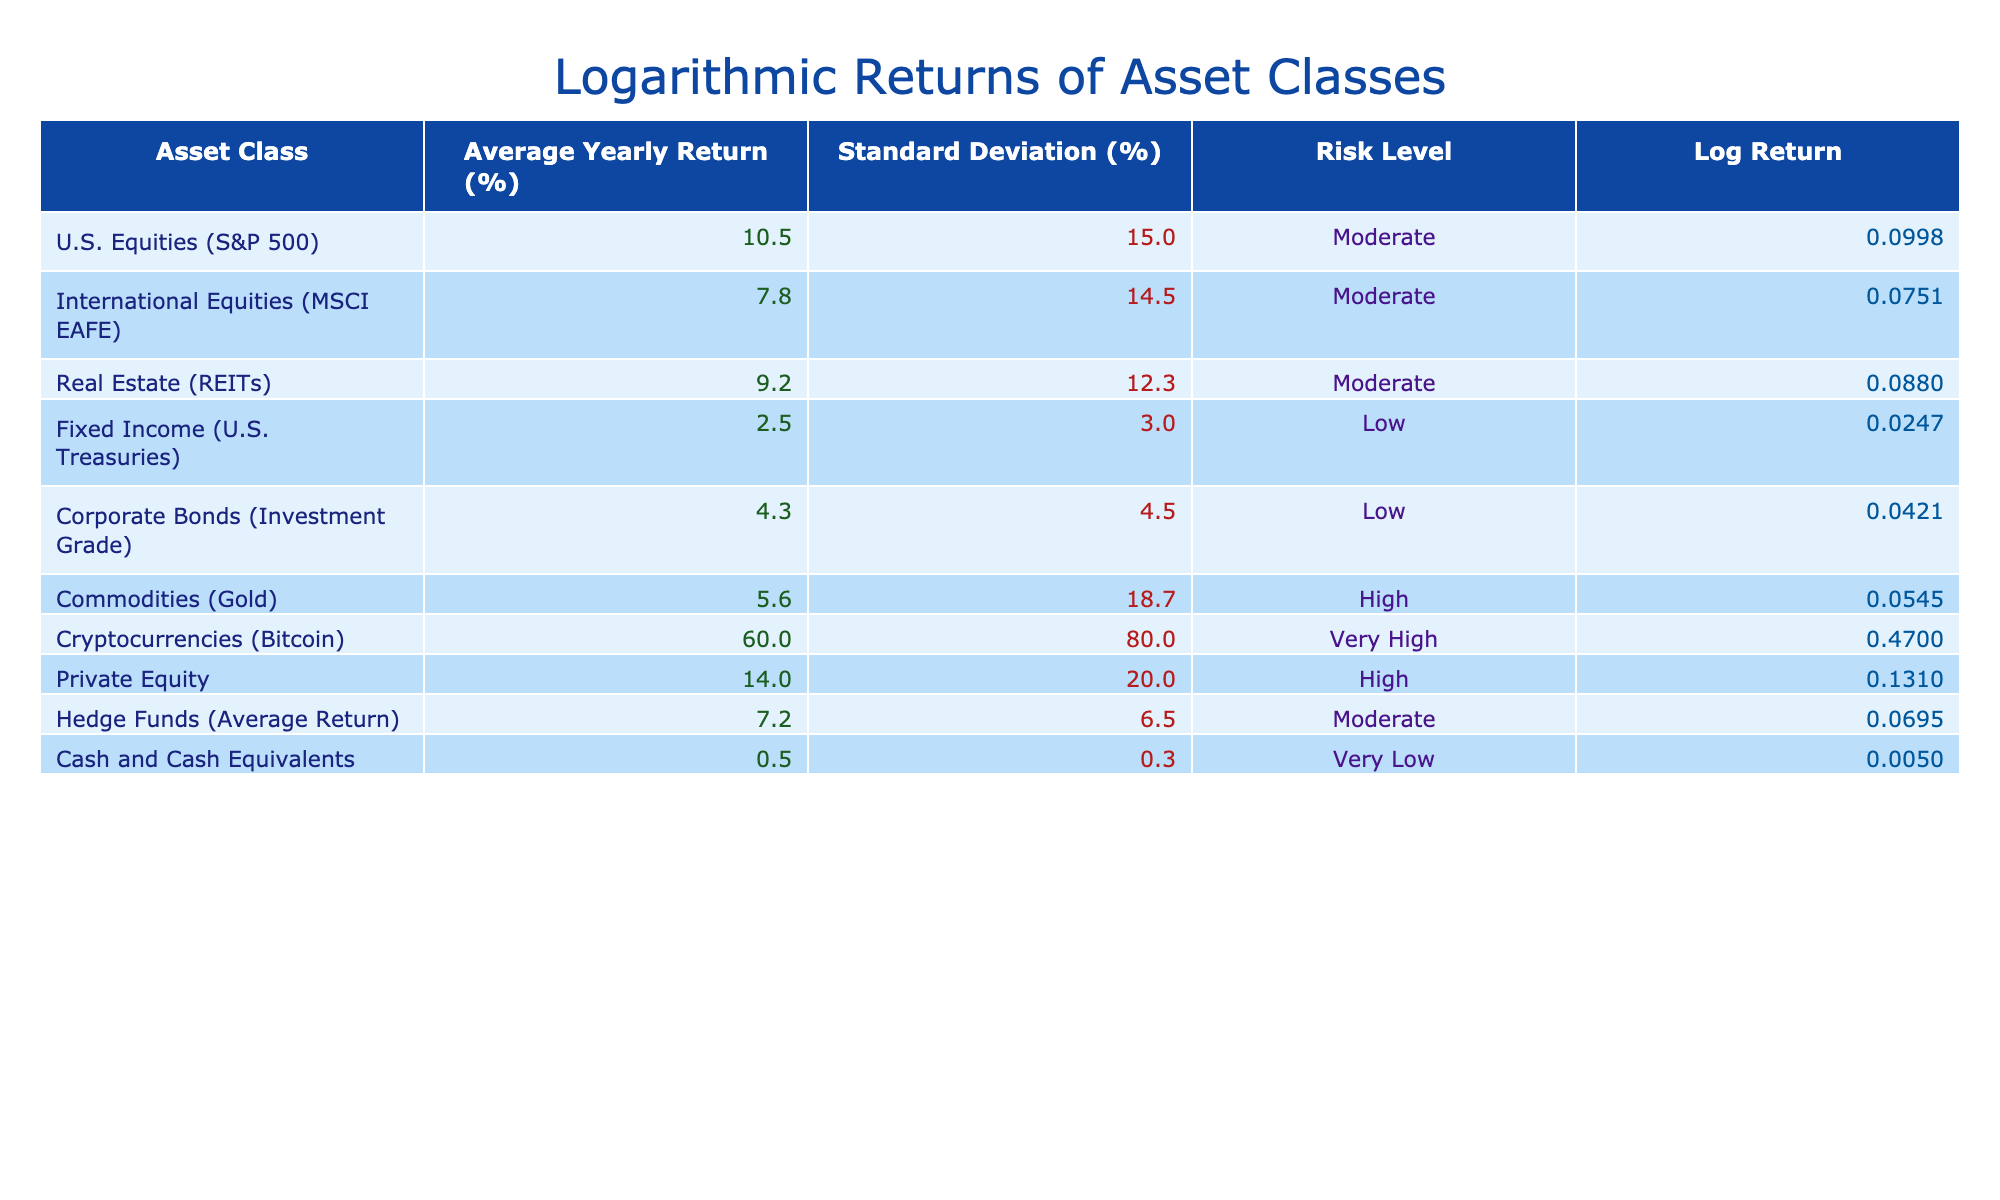What is the average yearly return of U.S. Equities? The table shows the average yearly return for U.S. Equities (S&P 500) is 10.5%. This value is directly listed under the "Average Yearly Return (%)" column for the corresponding asset class.
Answer: 10.5% Which asset class has the highest standard deviation? To find the asset class with the highest standard deviation, we compare the values in the "Standard Deviation (%)" column. The highest value is 80.0%, which corresponds to Cryptocurrencies (Bitcoin).
Answer: Cryptocurrencies (Bitcoin) What is the average standard deviation of Fixed Income and Corporate Bonds? The standard deviation for Fixed Income (U.S. Treasuries) is 3.0%, and for Corporate Bonds (Investment Grade) it is 4.5%. To find the average, we sum these two values (3.0 + 4.5 = 7.5) and divide by 2, resulting in an average of 7.5 / 2 = 3.75%.
Answer: 3.75% Is the risk level for Real Estate the same as that for International Equities? Both Real Estate (REITs) and International Equities (MSCI EAFE) have a risk level categorized as "Moderate," which means their risk levels are indeed the same.
Answer: Yes Which asset class has the lowest average yearly return, and what is that return? The table indicates that Cash and Cash Equivalents have the lowest average yearly return at 0.5%. This is found by comparing the values in the "Average Yearly Return (%)" column.
Answer: Cash and Cash Equivalents, 0.5% What is the difference in average yearly returns between Private Equity and Hedge Funds? The average yearly return for Private Equity is 14.0%, and for Hedge Funds (Average Return) it is 7.2%. The difference is calculated by subtracting Hedge Funds from Private Equity (14.0 - 7.2 = 6.8%).
Answer: 6.8% Which asset class has the highest average yearly return among those with a "Moderate" risk level? The asset classes with a "Moderate" risk level are U.S. Equities (10.5%), International Equities (7.8%), Real Estate (9.2%), and Hedge Funds (7.2%). By comparing these values, U.S. Equities has the highest return at 10.5%.
Answer: U.S. Equities (S&P 500), 10.5% If an investment portfolio is composed of two asset classes: U.S. Equities and Cryptocurrencies, what would be the weighted average return if the investment is 70% in U.S. Equities and 30% in Cryptocurrencies? The average yearly return for U.S. Equities is 10.5% and for Cryptocurrencies it is 60%. The weighted average return is calculated as follows: (0.7 * 10.5) + (0.3 * 60) = 7.35 + 18 = 25.35%.
Answer: 25.35% 